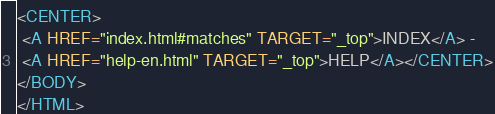Convert code to text. <code><loc_0><loc_0><loc_500><loc_500><_HTML_><CENTER>
 <A HREF="index.html#matches" TARGET="_top">INDEX</A> - 
 <A HREF="help-en.html" TARGET="_top">HELP</A></CENTER>
</BODY>
</HTML>
</code> 